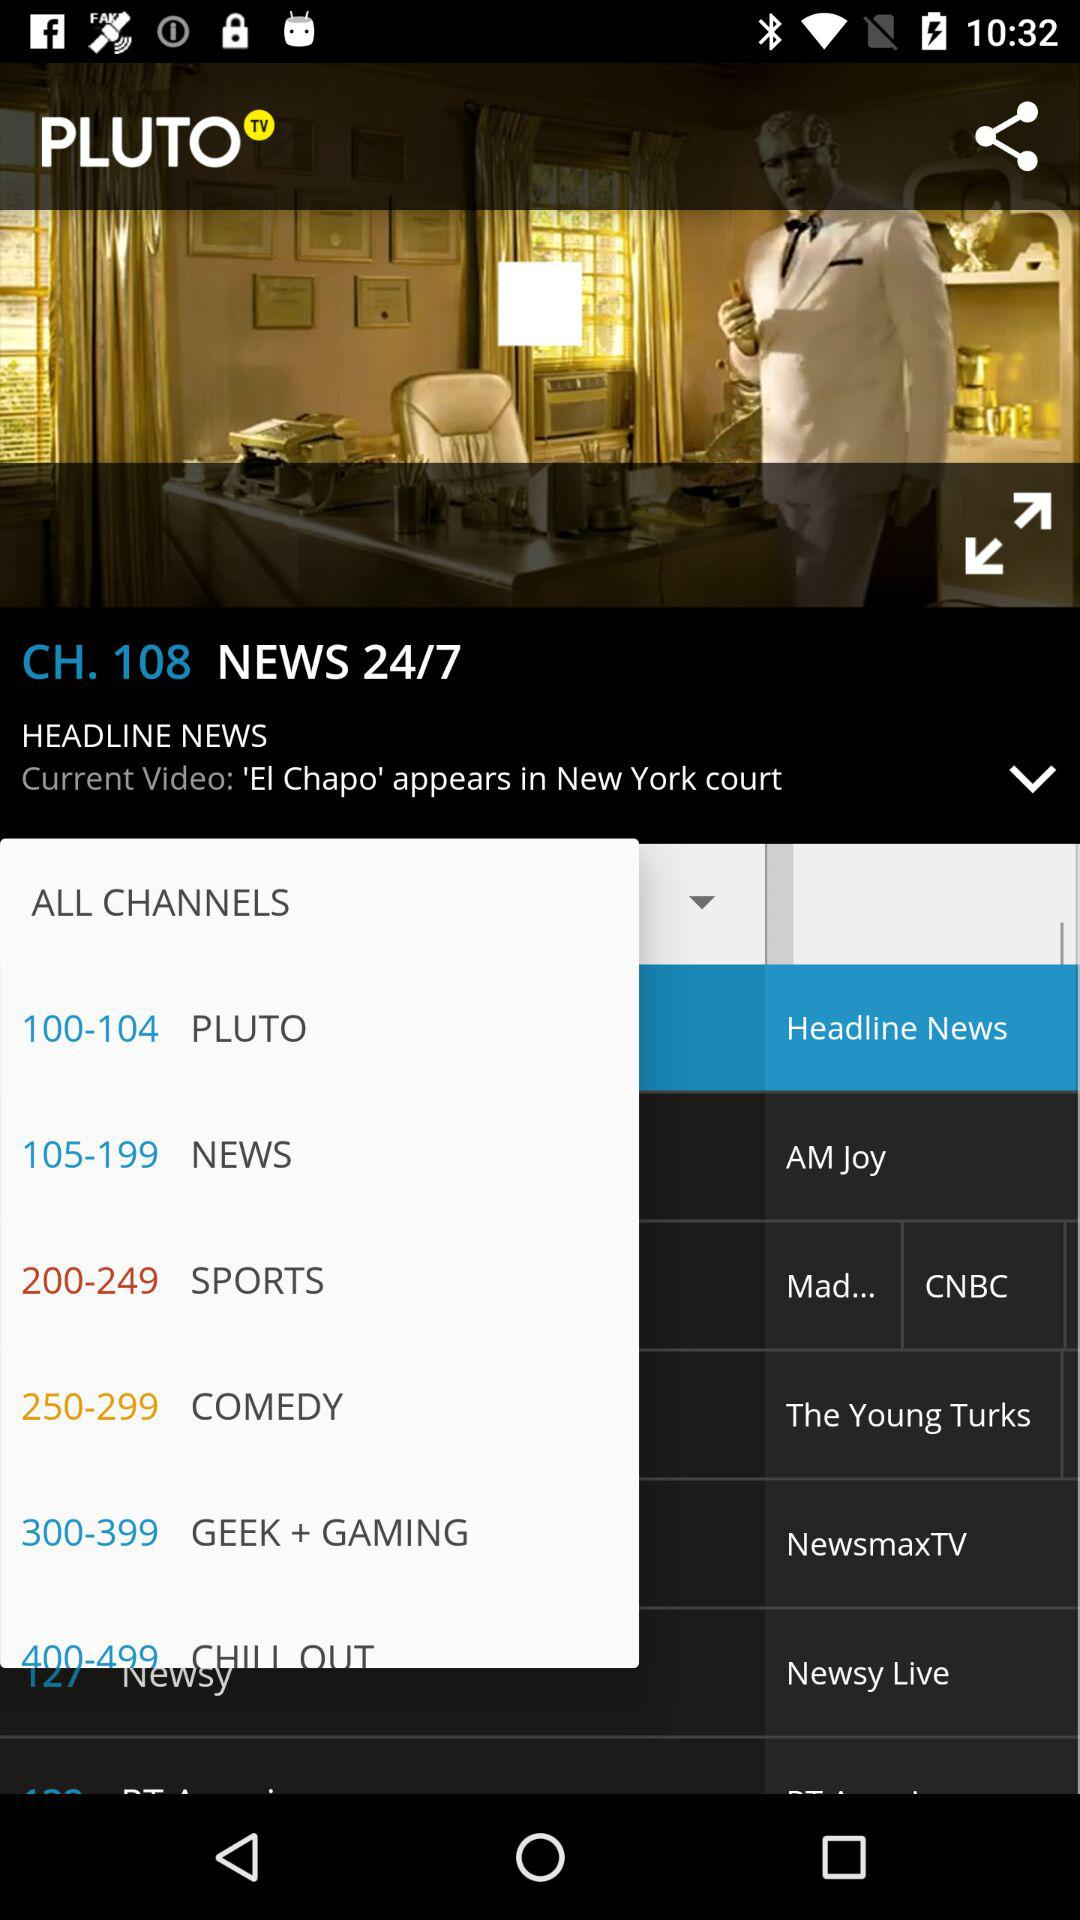What is the app name? The app name is "PLUTO TV". 